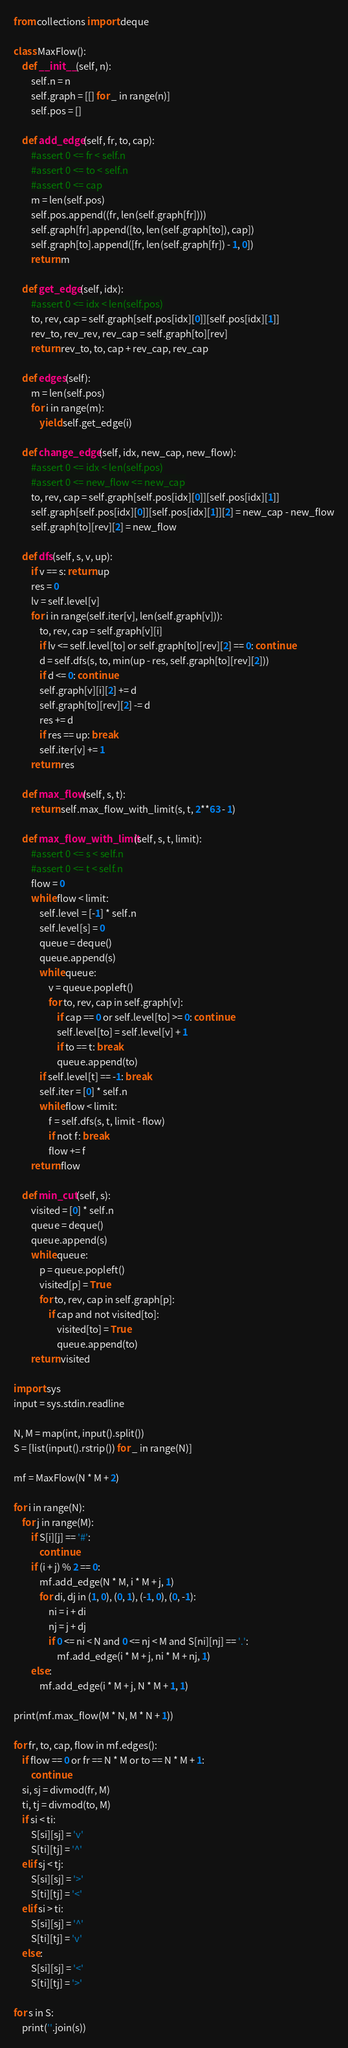Convert code to text. <code><loc_0><loc_0><loc_500><loc_500><_Python_>from collections import deque

class MaxFlow():
    def __init__(self, n):
        self.n = n
        self.graph = [[] for _ in range(n)]
        self.pos = []

    def add_edge(self, fr, to, cap):
        #assert 0 <= fr < self.n
        #assert 0 <= to < self.n
        #assert 0 <= cap
        m = len(self.pos)
        self.pos.append((fr, len(self.graph[fr])))
        self.graph[fr].append([to, len(self.graph[to]), cap])
        self.graph[to].append([fr, len(self.graph[fr]) - 1, 0])
        return m

    def get_edge(self, idx):
        #assert 0 <= idx < len(self.pos)
        to, rev, cap = self.graph[self.pos[idx][0]][self.pos[idx][1]]
        rev_to, rev_rev, rev_cap = self.graph[to][rev]
        return rev_to, to, cap + rev_cap, rev_cap

    def edges(self):
        m = len(self.pos)
        for i in range(m):
            yield self.get_edge(i)

    def change_edge(self, idx, new_cap, new_flow):
        #assert 0 <= idx < len(self.pos)
        #assert 0 <= new_flow <= new_cap
        to, rev, cap = self.graph[self.pos[idx][0]][self.pos[idx][1]]
        self.graph[self.pos[idx][0]][self.pos[idx][1]][2] = new_cap - new_flow
        self.graph[to][rev][2] = new_flow

    def dfs(self, s, v, up):
        if v == s: return up
        res = 0
        lv = self.level[v]
        for i in range(self.iter[v], len(self.graph[v])):
            to, rev, cap = self.graph[v][i]
            if lv <= self.level[to] or self.graph[to][rev][2] == 0: continue
            d = self.dfs(s, to, min(up - res, self.graph[to][rev][2]))
            if d <= 0: continue
            self.graph[v][i][2] += d
            self.graph[to][rev][2] -= d
            res += d
            if res == up: break
            self.iter[v] += 1
        return res

    def max_flow(self, s, t):
        return self.max_flow_with_limit(s, t, 2**63 - 1)

    def max_flow_with_limit(self, s, t, limit):
        #assert 0 <= s < self.n
        #assert 0 <= t < self.n
        flow = 0
        while flow < limit:
            self.level = [-1] * self.n
            self.level[s] = 0
            queue = deque()
            queue.append(s)
            while queue:
                v = queue.popleft()
                for to, rev, cap in self.graph[v]:
                    if cap == 0 or self.level[to] >= 0: continue
                    self.level[to] = self.level[v] + 1
                    if to == t: break
                    queue.append(to)
            if self.level[t] == -1: break
            self.iter = [0] * self.n
            while flow < limit:
                f = self.dfs(s, t, limit - flow)
                if not f: break
                flow += f
        return flow

    def min_cut(self, s):
        visited = [0] * self.n
        queue = deque()
        queue.append(s)
        while queue:
            p = queue.popleft()
            visited[p] = True
            for to, rev, cap in self.graph[p]:
                if cap and not visited[to]:
                    visited[to] = True
                    queue.append(to)
        return visited

import sys
input = sys.stdin.readline

N, M = map(int, input().split())
S = [list(input().rstrip()) for _ in range(N)]

mf = MaxFlow(N * M + 2)

for i in range(N):
    for j in range(M):
        if S[i][j] == '#':
            continue
        if (i + j) % 2 == 0:
            mf.add_edge(N * M, i * M + j, 1)
            for di, dj in (1, 0), (0, 1), (-1, 0), (0, -1):
                ni = i + di
                nj = j + dj
                if 0 <= ni < N and 0 <= nj < M and S[ni][nj] == '.':
                    mf.add_edge(i * M + j, ni * M + nj, 1)
        else:
            mf.add_edge(i * M + j, N * M + 1, 1)

print(mf.max_flow(M * N, M * N + 1))

for fr, to, cap, flow in mf.edges():
    if flow == 0 or fr == N * M or to == N * M + 1:
        continue
    si, sj = divmod(fr, M)
    ti, tj = divmod(to, M)
    if si < ti:
        S[si][sj] = 'v'
        S[ti][tj] = '^'
    elif sj < tj:
        S[si][sj] = '>'
        S[ti][tj] = '<'
    elif si > ti:
        S[si][sj] = '^'
        S[ti][tj] = 'v'
    else:
        S[si][sj] = '<'
        S[ti][tj] = '>'

for s in S:
    print(''.join(s))</code> 